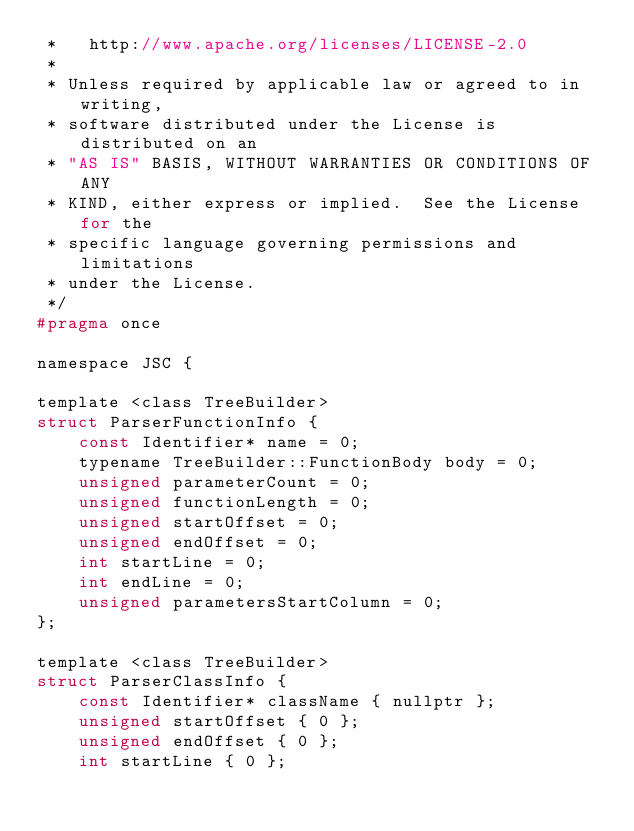Convert code to text. <code><loc_0><loc_0><loc_500><loc_500><_C_> *   http://www.apache.org/licenses/LICENSE-2.0
 *
 * Unless required by applicable law or agreed to in writing,
 * software distributed under the License is distributed on an
 * "AS IS" BASIS, WITHOUT WARRANTIES OR CONDITIONS OF ANY
 * KIND, either express or implied.  See the License for the
 * specific language governing permissions and limitations
 * under the License.
 */
#pragma once

namespace JSC {

template <class TreeBuilder>
struct ParserFunctionInfo {
    const Identifier* name = 0;
    typename TreeBuilder::FunctionBody body = 0;
    unsigned parameterCount = 0;
    unsigned functionLength = 0;
    unsigned startOffset = 0;
    unsigned endOffset = 0;
    int startLine = 0;
    int endLine = 0;
    unsigned parametersStartColumn = 0;
};

template <class TreeBuilder>
struct ParserClassInfo {
    const Identifier* className { nullptr };
    unsigned startOffset { 0 };
    unsigned endOffset { 0 };
    int startLine { 0 };</code> 